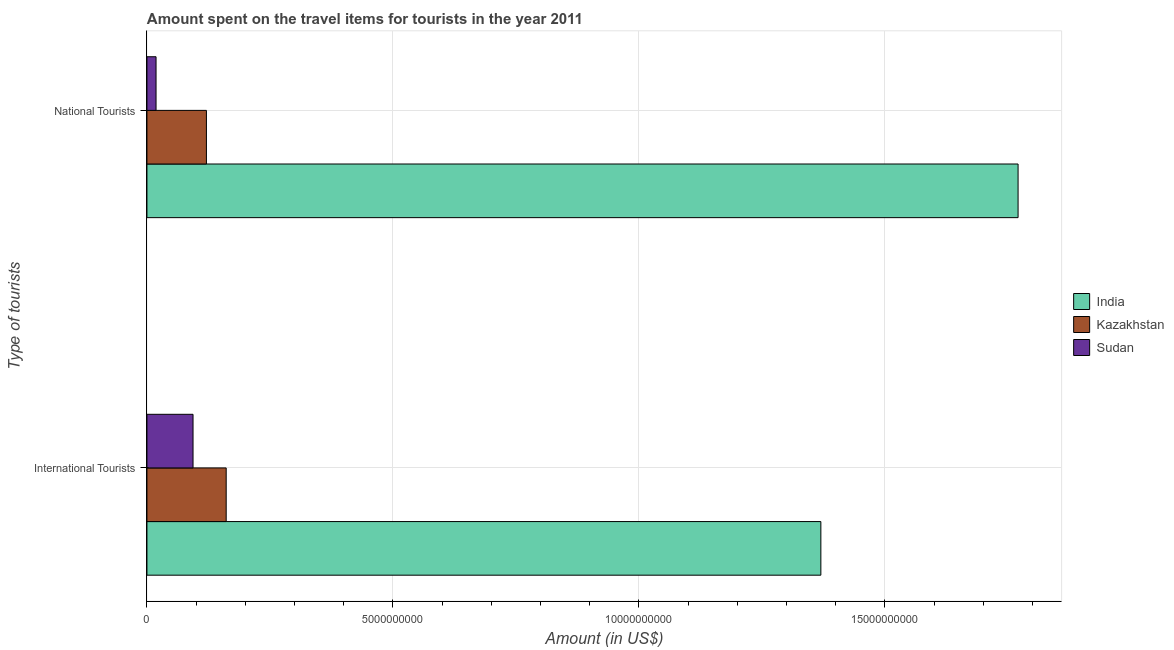How many different coloured bars are there?
Provide a succinct answer. 3. Are the number of bars per tick equal to the number of legend labels?
Give a very brief answer. Yes. How many bars are there on the 2nd tick from the top?
Your answer should be compact. 3. How many bars are there on the 1st tick from the bottom?
Keep it short and to the point. 3. What is the label of the 1st group of bars from the top?
Offer a very short reply. National Tourists. What is the amount spent on travel items of national tourists in Sudan?
Provide a short and direct response. 1.85e+08. Across all countries, what is the maximum amount spent on travel items of national tourists?
Keep it short and to the point. 1.77e+1. Across all countries, what is the minimum amount spent on travel items of national tourists?
Offer a very short reply. 1.85e+08. In which country was the amount spent on travel items of international tourists minimum?
Offer a terse response. Sudan. What is the total amount spent on travel items of international tourists in the graph?
Offer a very short reply. 1.62e+1. What is the difference between the amount spent on travel items of national tourists in Kazakhstan and that in India?
Provide a short and direct response. -1.65e+1. What is the difference between the amount spent on travel items of international tourists in India and the amount spent on travel items of national tourists in Sudan?
Your response must be concise. 1.35e+1. What is the average amount spent on travel items of international tourists per country?
Give a very brief answer. 5.42e+09. What is the difference between the amount spent on travel items of international tourists and amount spent on travel items of national tourists in Kazakhstan?
Make the answer very short. 4.02e+08. In how many countries, is the amount spent on travel items of international tourists greater than 16000000000 US$?
Provide a short and direct response. 0. What is the ratio of the amount spent on travel items of international tourists in Kazakhstan to that in Sudan?
Ensure brevity in your answer.  1.72. What does the 1st bar from the top in International Tourists represents?
Offer a very short reply. Sudan. What does the 3rd bar from the bottom in National Tourists represents?
Keep it short and to the point. Sudan. How many countries are there in the graph?
Give a very brief answer. 3. What is the difference between two consecutive major ticks on the X-axis?
Give a very brief answer. 5.00e+09. Are the values on the major ticks of X-axis written in scientific E-notation?
Your answer should be very brief. No. Does the graph contain any zero values?
Ensure brevity in your answer.  No. Does the graph contain grids?
Provide a succinct answer. Yes. How many legend labels are there?
Your response must be concise. 3. What is the title of the graph?
Offer a terse response. Amount spent on the travel items for tourists in the year 2011. What is the label or title of the Y-axis?
Your response must be concise. Type of tourists. What is the Amount (in US$) of India in International Tourists?
Your answer should be compact. 1.37e+1. What is the Amount (in US$) in Kazakhstan in International Tourists?
Your response must be concise. 1.61e+09. What is the Amount (in US$) in Sudan in International Tourists?
Your response must be concise. 9.37e+08. What is the Amount (in US$) of India in National Tourists?
Make the answer very short. 1.77e+1. What is the Amount (in US$) in Kazakhstan in National Tourists?
Offer a very short reply. 1.21e+09. What is the Amount (in US$) of Sudan in National Tourists?
Ensure brevity in your answer.  1.85e+08. Across all Type of tourists, what is the maximum Amount (in US$) in India?
Make the answer very short. 1.77e+1. Across all Type of tourists, what is the maximum Amount (in US$) in Kazakhstan?
Keep it short and to the point. 1.61e+09. Across all Type of tourists, what is the maximum Amount (in US$) of Sudan?
Give a very brief answer. 9.37e+08. Across all Type of tourists, what is the minimum Amount (in US$) in India?
Keep it short and to the point. 1.37e+1. Across all Type of tourists, what is the minimum Amount (in US$) in Kazakhstan?
Ensure brevity in your answer.  1.21e+09. Across all Type of tourists, what is the minimum Amount (in US$) in Sudan?
Offer a terse response. 1.85e+08. What is the total Amount (in US$) of India in the graph?
Your response must be concise. 3.14e+1. What is the total Amount (in US$) of Kazakhstan in the graph?
Provide a short and direct response. 2.82e+09. What is the total Amount (in US$) in Sudan in the graph?
Your response must be concise. 1.12e+09. What is the difference between the Amount (in US$) of India in International Tourists and that in National Tourists?
Your answer should be compact. -4.01e+09. What is the difference between the Amount (in US$) of Kazakhstan in International Tourists and that in National Tourists?
Keep it short and to the point. 4.02e+08. What is the difference between the Amount (in US$) of Sudan in International Tourists and that in National Tourists?
Offer a terse response. 7.52e+08. What is the difference between the Amount (in US$) in India in International Tourists and the Amount (in US$) in Kazakhstan in National Tourists?
Ensure brevity in your answer.  1.25e+1. What is the difference between the Amount (in US$) of India in International Tourists and the Amount (in US$) of Sudan in National Tourists?
Offer a very short reply. 1.35e+1. What is the difference between the Amount (in US$) of Kazakhstan in International Tourists and the Amount (in US$) of Sudan in National Tourists?
Make the answer very short. 1.43e+09. What is the average Amount (in US$) in India per Type of tourists?
Offer a terse response. 1.57e+1. What is the average Amount (in US$) in Kazakhstan per Type of tourists?
Your response must be concise. 1.41e+09. What is the average Amount (in US$) in Sudan per Type of tourists?
Provide a short and direct response. 5.61e+08. What is the difference between the Amount (in US$) of India and Amount (in US$) of Kazakhstan in International Tourists?
Your answer should be compact. 1.21e+1. What is the difference between the Amount (in US$) of India and Amount (in US$) of Sudan in International Tourists?
Make the answer very short. 1.28e+1. What is the difference between the Amount (in US$) of Kazakhstan and Amount (in US$) of Sudan in International Tourists?
Offer a very short reply. 6.74e+08. What is the difference between the Amount (in US$) in India and Amount (in US$) in Kazakhstan in National Tourists?
Keep it short and to the point. 1.65e+1. What is the difference between the Amount (in US$) in India and Amount (in US$) in Sudan in National Tourists?
Make the answer very short. 1.75e+1. What is the difference between the Amount (in US$) in Kazakhstan and Amount (in US$) in Sudan in National Tourists?
Provide a short and direct response. 1.02e+09. What is the ratio of the Amount (in US$) of India in International Tourists to that in National Tourists?
Keep it short and to the point. 0.77. What is the ratio of the Amount (in US$) in Kazakhstan in International Tourists to that in National Tourists?
Offer a very short reply. 1.33. What is the ratio of the Amount (in US$) of Sudan in International Tourists to that in National Tourists?
Your response must be concise. 5.06. What is the difference between the highest and the second highest Amount (in US$) in India?
Give a very brief answer. 4.01e+09. What is the difference between the highest and the second highest Amount (in US$) of Kazakhstan?
Provide a short and direct response. 4.02e+08. What is the difference between the highest and the second highest Amount (in US$) of Sudan?
Keep it short and to the point. 7.52e+08. What is the difference between the highest and the lowest Amount (in US$) in India?
Provide a succinct answer. 4.01e+09. What is the difference between the highest and the lowest Amount (in US$) in Kazakhstan?
Your answer should be compact. 4.02e+08. What is the difference between the highest and the lowest Amount (in US$) in Sudan?
Provide a short and direct response. 7.52e+08. 